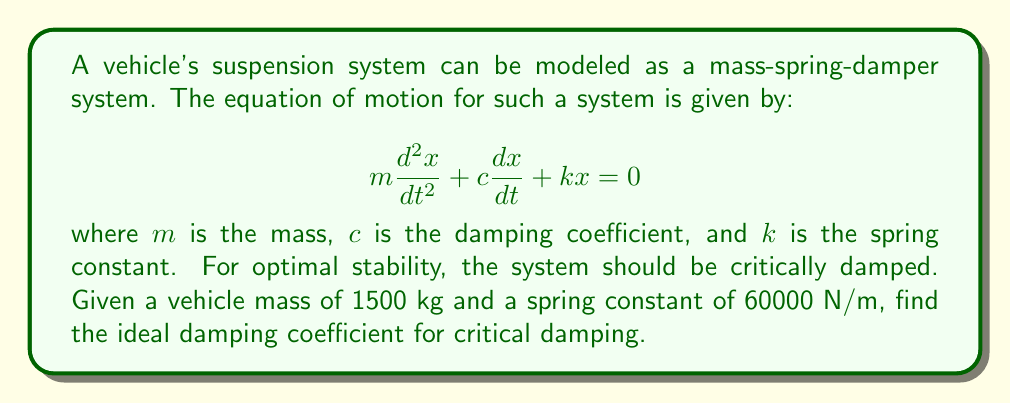Help me with this question. To solve this problem, we'll follow these steps:

1) Recall that for a system to be critically damped, its damping ratio $\zeta$ must equal 1. The damping ratio is given by:

   $$\zeta = \frac{c}{2\sqrt{km}}$$

2) Set this equal to 1 and solve for c:

   $$1 = \frac{c}{2\sqrt{km}}$$
   $$2\sqrt{km} = c$$

3) Now, substitute the given values:
   $m = 1500$ kg
   $k = 60000$ N/m

4) Calculate:

   $$c = 2\sqrt{60000 \cdot 1500}$$
   $$c = 2\sqrt{90000000}$$
   $$c = 2 \cdot 9486.83$$
   $$c = 18973.67$$

5) Round to the nearest whole number:

   $$c \approx 18974$$ N·s/m

This is the ideal damping coefficient for critical damping given the mass and spring constant.
Answer: 18974 N·s/m 